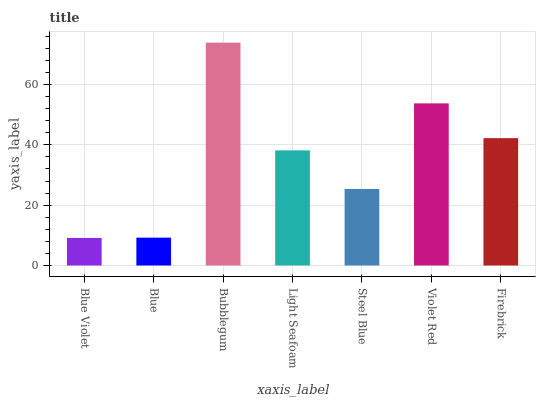Is Blue Violet the minimum?
Answer yes or no. Yes. Is Bubblegum the maximum?
Answer yes or no. Yes. Is Blue the minimum?
Answer yes or no. No. Is Blue the maximum?
Answer yes or no. No. Is Blue greater than Blue Violet?
Answer yes or no. Yes. Is Blue Violet less than Blue?
Answer yes or no. Yes. Is Blue Violet greater than Blue?
Answer yes or no. No. Is Blue less than Blue Violet?
Answer yes or no. No. Is Light Seafoam the high median?
Answer yes or no. Yes. Is Light Seafoam the low median?
Answer yes or no. Yes. Is Blue Violet the high median?
Answer yes or no. No. Is Firebrick the low median?
Answer yes or no. No. 